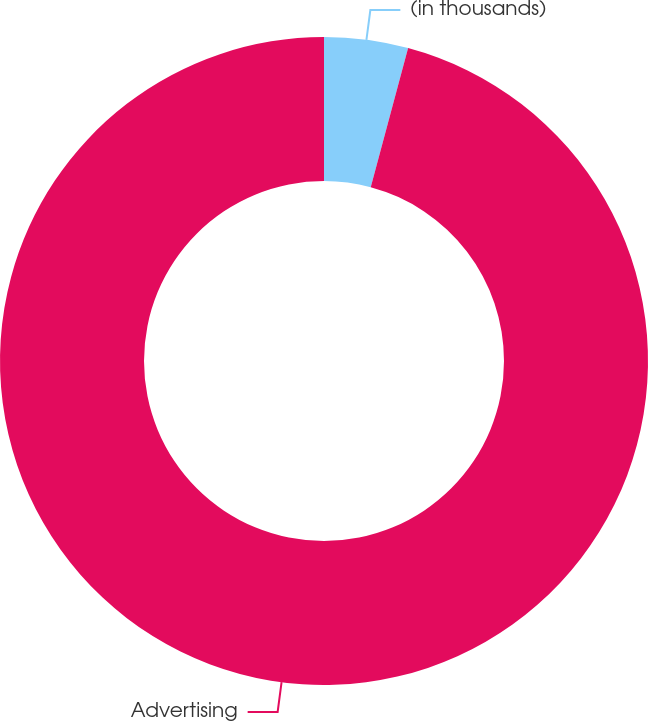Convert chart. <chart><loc_0><loc_0><loc_500><loc_500><pie_chart><fcel>(in thousands)<fcel>Advertising<nl><fcel>4.18%<fcel>95.82%<nl></chart> 